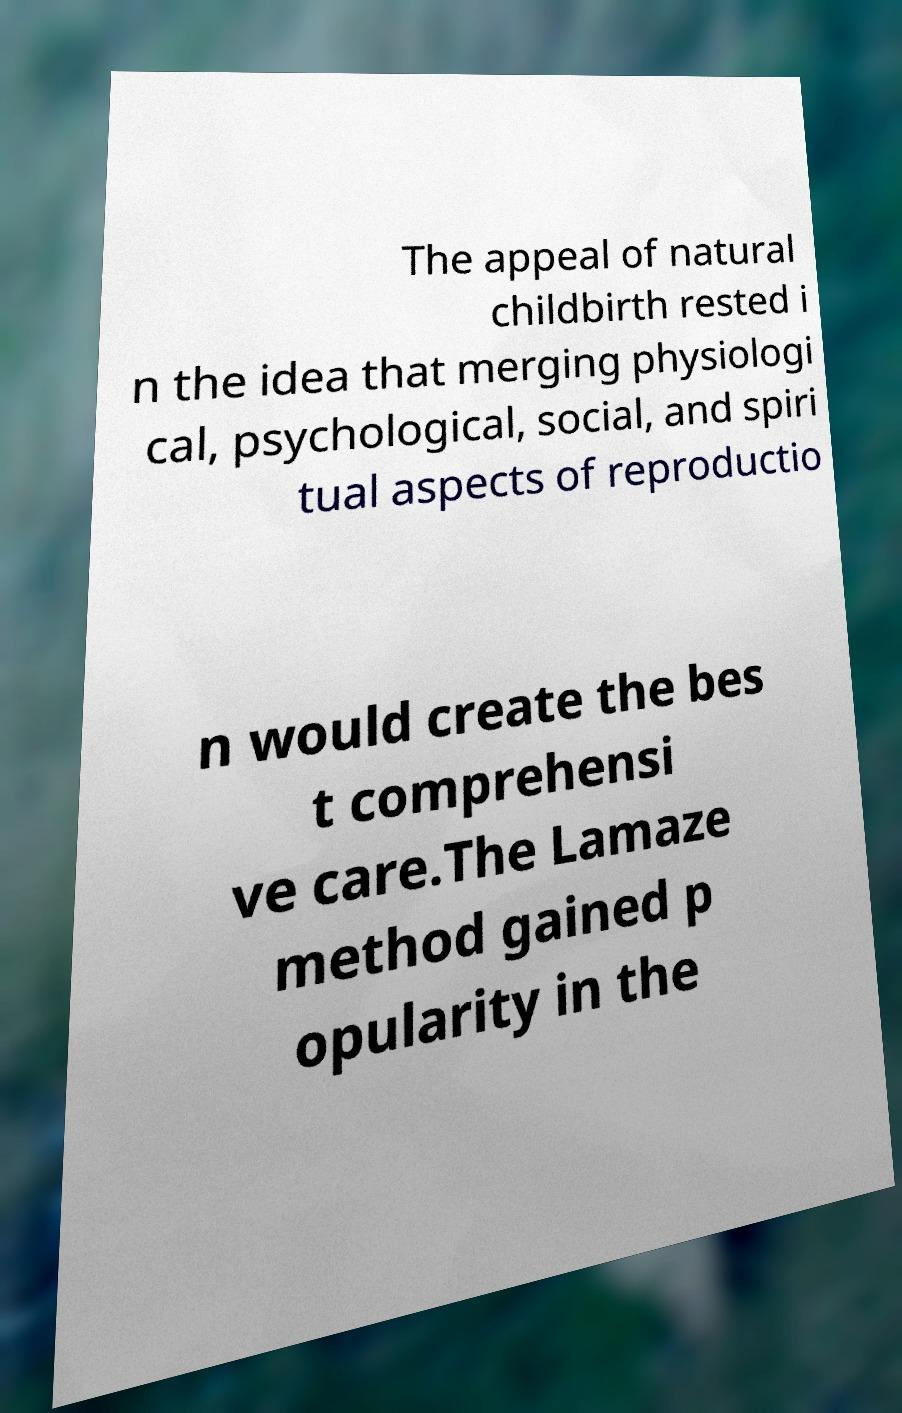Can you accurately transcribe the text from the provided image for me? The appeal of natural childbirth rested i n the idea that merging physiologi cal, psychological, social, and spiri tual aspects of reproductio n would create the bes t comprehensi ve care.The Lamaze method gained p opularity in the 